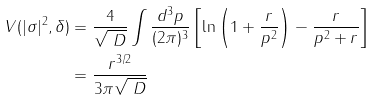Convert formula to latex. <formula><loc_0><loc_0><loc_500><loc_500>V ( | \sigma | ^ { 2 } , \delta ) & = \frac { 4 } { \sqrt { \ D } } \int \frac { d ^ { 3 } p } { ( 2 \pi ) ^ { 3 } } \left [ \ln \left ( 1 + \frac { r } { p ^ { 2 } } \right ) - \frac { r } { p ^ { 2 } + r } \right ] \\ & = \frac { r ^ { 3 / 2 } } { 3 \pi \sqrt { \ D } }</formula> 